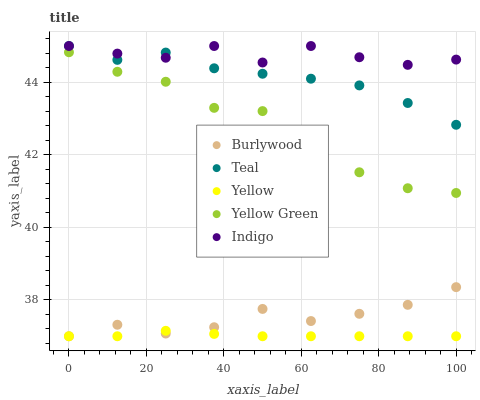Does Yellow have the minimum area under the curve?
Answer yes or no. Yes. Does Indigo have the maximum area under the curve?
Answer yes or no. Yes. Does Indigo have the minimum area under the curve?
Answer yes or no. No. Does Yellow have the maximum area under the curve?
Answer yes or no. No. Is Yellow the smoothest?
Answer yes or no. Yes. Is Indigo the roughest?
Answer yes or no. Yes. Is Indigo the smoothest?
Answer yes or no. No. Is Yellow the roughest?
Answer yes or no. No. Does Burlywood have the lowest value?
Answer yes or no. Yes. Does Indigo have the lowest value?
Answer yes or no. No. Does Teal have the highest value?
Answer yes or no. Yes. Does Yellow have the highest value?
Answer yes or no. No. Is Yellow less than Yellow Green?
Answer yes or no. Yes. Is Teal greater than Yellow Green?
Answer yes or no. Yes. Does Teal intersect Indigo?
Answer yes or no. Yes. Is Teal less than Indigo?
Answer yes or no. No. Is Teal greater than Indigo?
Answer yes or no. No. Does Yellow intersect Yellow Green?
Answer yes or no. No. 